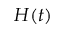Convert formula to latex. <formula><loc_0><loc_0><loc_500><loc_500>H ( t )</formula> 